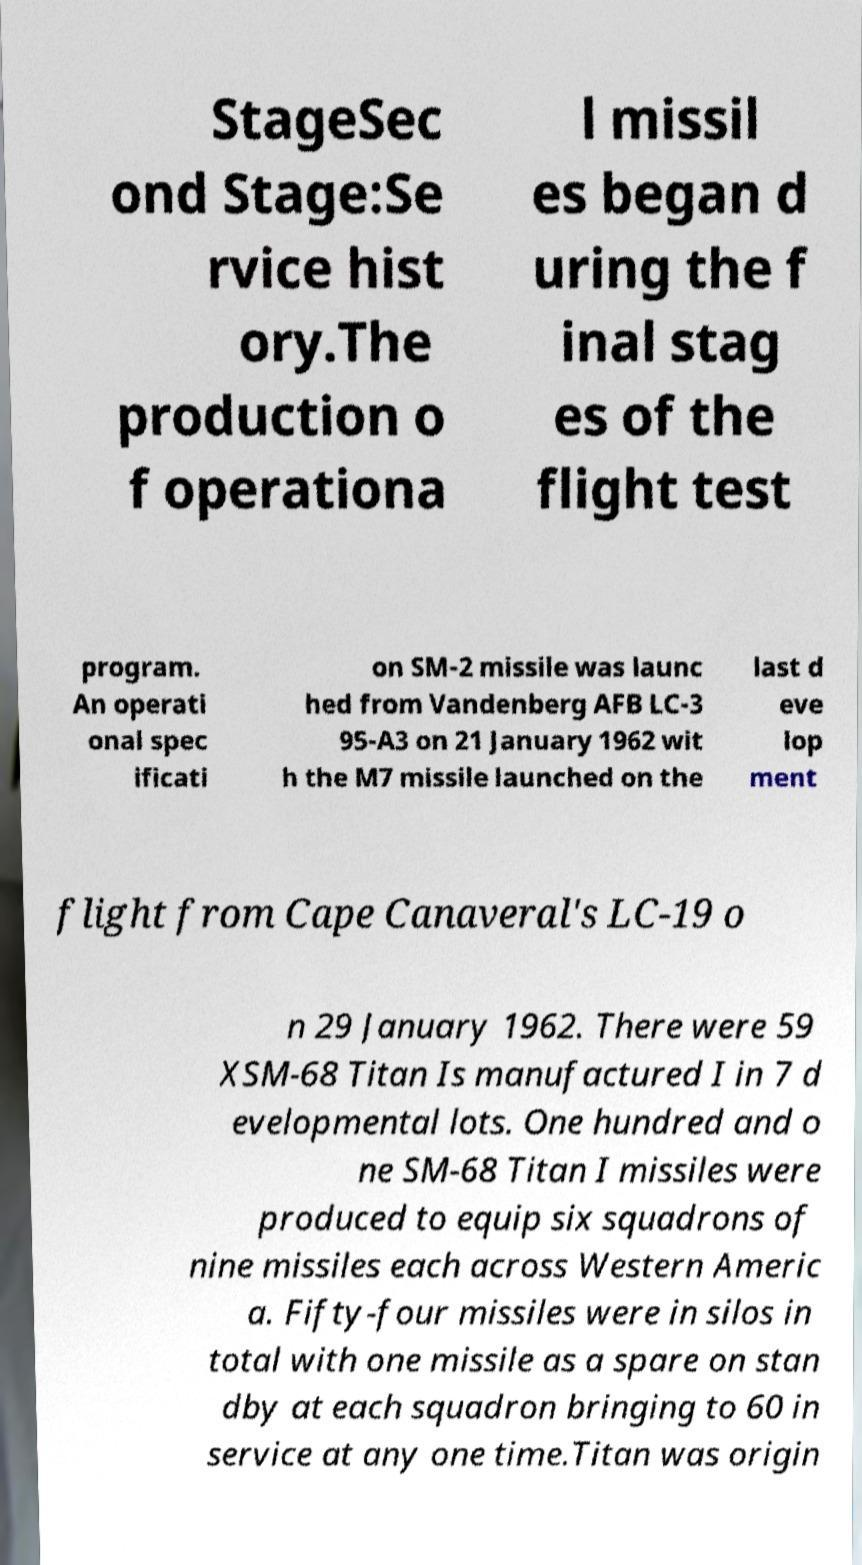For documentation purposes, I need the text within this image transcribed. Could you provide that? StageSec ond Stage:Se rvice hist ory.The production o f operationa l missil es began d uring the f inal stag es of the flight test program. An operati onal spec ificati on SM-2 missile was launc hed from Vandenberg AFB LC-3 95-A3 on 21 January 1962 wit h the M7 missile launched on the last d eve lop ment flight from Cape Canaveral's LC-19 o n 29 January 1962. There were 59 XSM-68 Titan Is manufactured I in 7 d evelopmental lots. One hundred and o ne SM-68 Titan I missiles were produced to equip six squadrons of nine missiles each across Western Americ a. Fifty-four missiles were in silos in total with one missile as a spare on stan dby at each squadron bringing to 60 in service at any one time.Titan was origin 